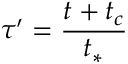<formula> <loc_0><loc_0><loc_500><loc_500>\tau ^ { \prime } = \frac { t + t _ { c } } { t _ { \ast } }</formula> 